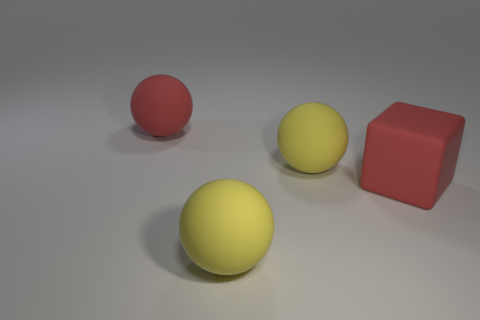Add 1 red matte spheres. How many objects exist? 5 Subtract all blocks. How many objects are left? 3 Subtract all big red cubes. Subtract all red matte spheres. How many objects are left? 2 Add 1 large rubber cubes. How many large rubber cubes are left? 2 Add 4 red matte objects. How many red matte objects exist? 6 Subtract 1 yellow balls. How many objects are left? 3 